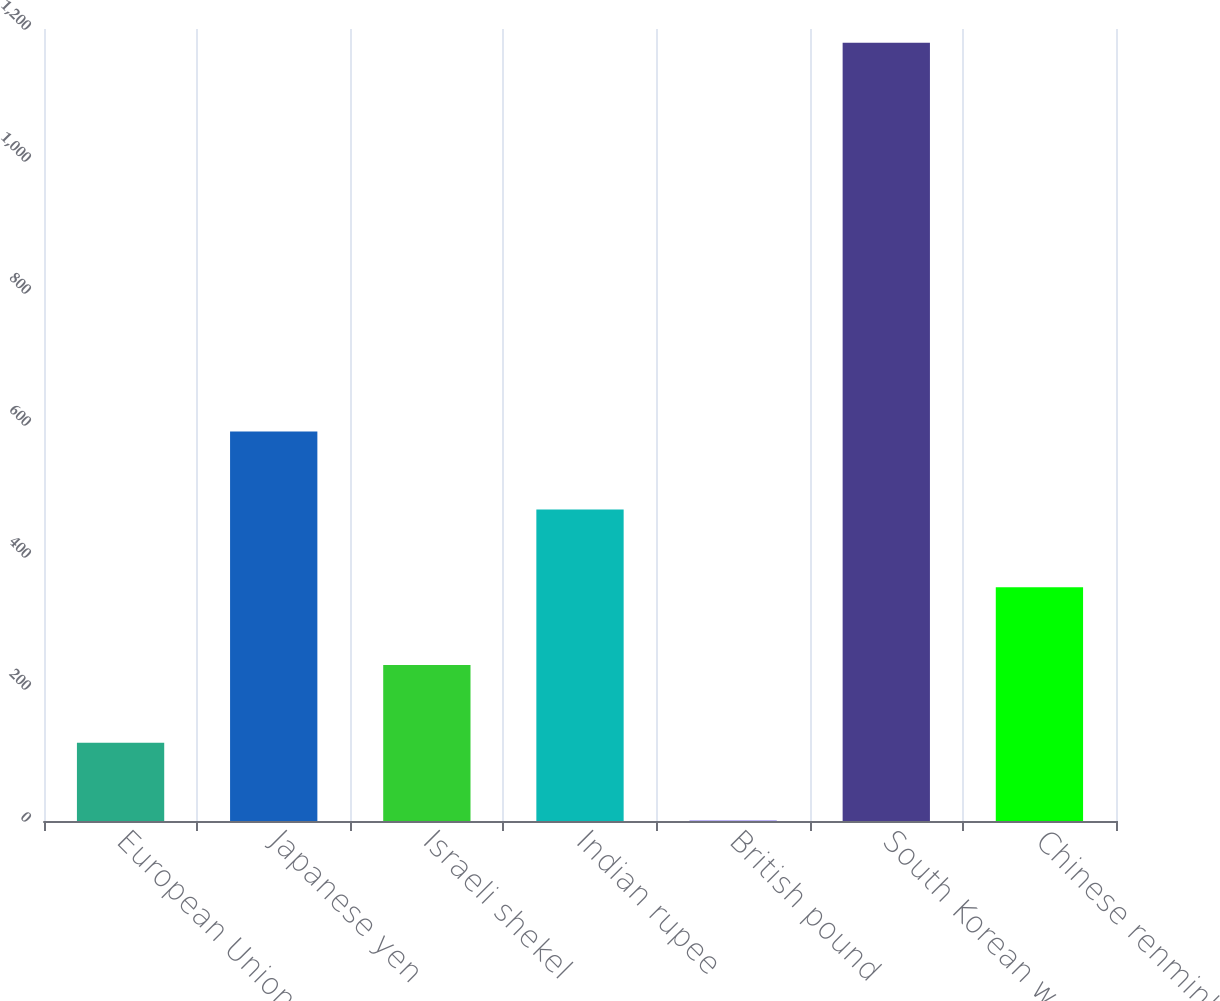Convert chart to OTSL. <chart><loc_0><loc_0><loc_500><loc_500><bar_chart><fcel>European Union euro<fcel>Japanese yen<fcel>Israeli shekel<fcel>Indian rupee<fcel>British pound<fcel>South Korean won<fcel>Chinese renminbi<nl><fcel>118.63<fcel>589.99<fcel>236.47<fcel>472.15<fcel>0.79<fcel>1179.14<fcel>354.31<nl></chart> 